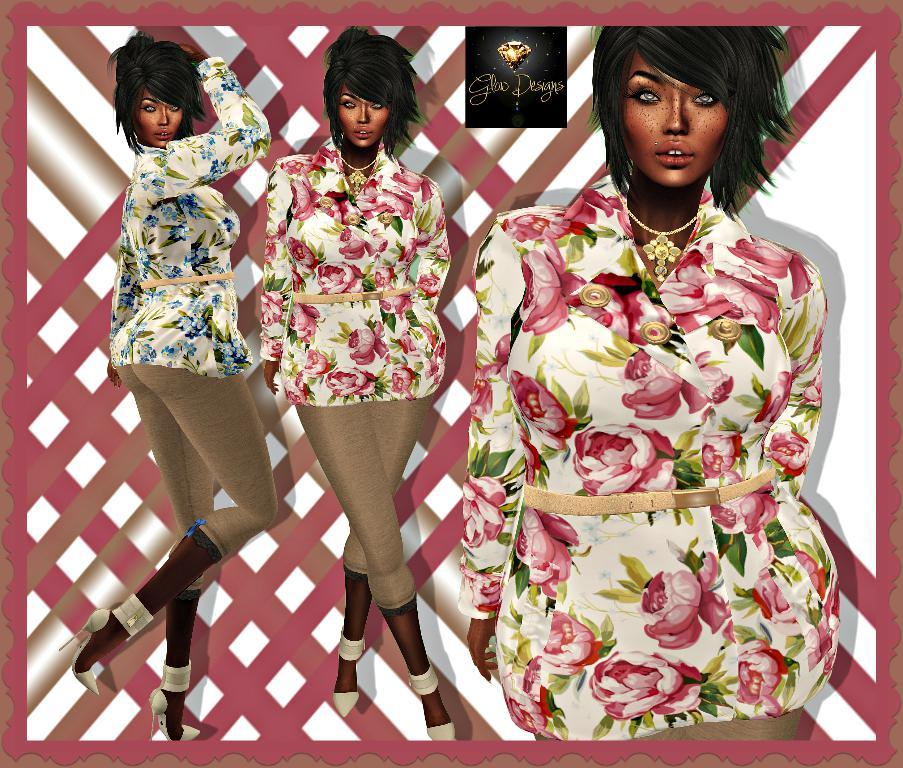What is the main subject of the image? The main subject of the image is an animated picture of a woman. Can you describe the woman in the image? Unfortunately, the provided facts do not include a description of the woman in the image. What type of animation is used in the image? The facts do not specify the type of animation used in the image. How much debt does the woman in the image owe? There is no information about debt in the image, as it only contains an animated picture of a woman. What type of patch is visible on the woman's clothing in the image? There is no information about clothing or patches in the image, as it only contains an animated picture of a woman. 